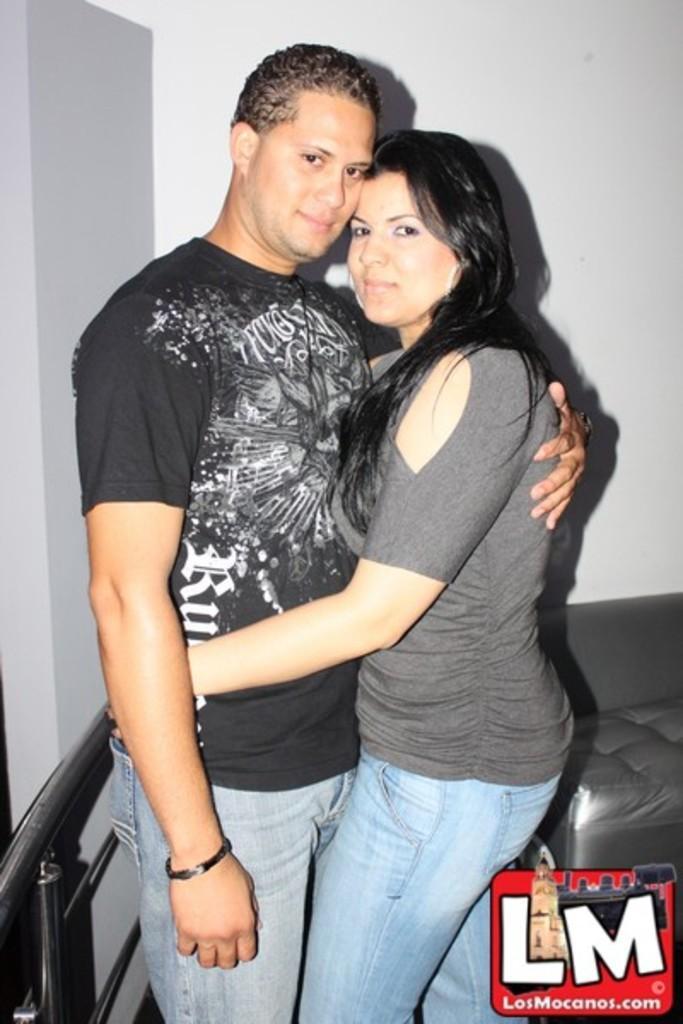In one or two sentences, can you explain what this image depicts? In this image we can see a two persons are standing, he is wearing the black color t-shirt, at back here is the sofa, here is the wall. 